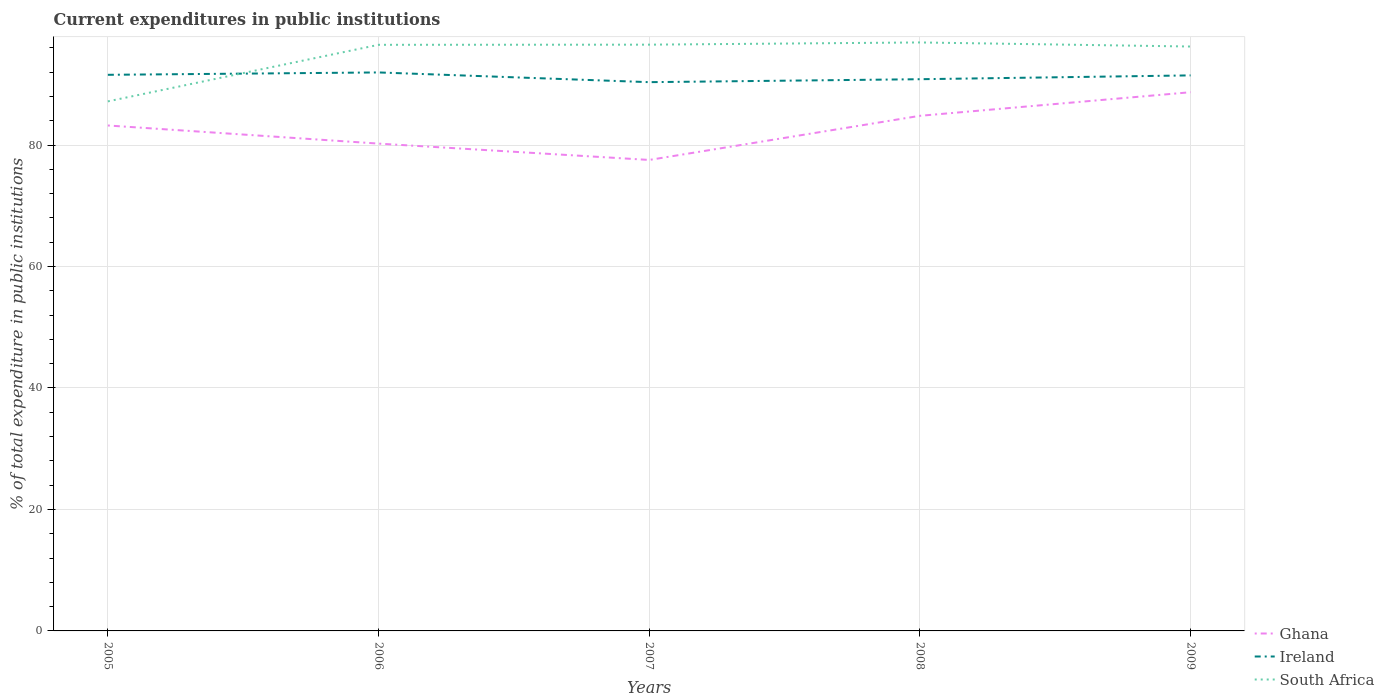How many different coloured lines are there?
Your answer should be very brief. 3. Across all years, what is the maximum current expenditures in public institutions in Ghana?
Offer a very short reply. 77.54. In which year was the current expenditures in public institutions in Ghana maximum?
Offer a very short reply. 2007. What is the total current expenditures in public institutions in Ghana in the graph?
Offer a very short reply. 2.98. What is the difference between the highest and the second highest current expenditures in public institutions in Ghana?
Your answer should be very brief. 11.15. Is the current expenditures in public institutions in South Africa strictly greater than the current expenditures in public institutions in Ghana over the years?
Offer a terse response. No. How many lines are there?
Your answer should be very brief. 3. Does the graph contain any zero values?
Your answer should be very brief. No. Does the graph contain grids?
Offer a terse response. Yes. How many legend labels are there?
Make the answer very short. 3. What is the title of the graph?
Offer a terse response. Current expenditures in public institutions. Does "Djibouti" appear as one of the legend labels in the graph?
Ensure brevity in your answer.  No. What is the label or title of the Y-axis?
Offer a terse response. % of total expenditure in public institutions. What is the % of total expenditure in public institutions of Ghana in 2005?
Your answer should be very brief. 83.22. What is the % of total expenditure in public institutions in Ireland in 2005?
Give a very brief answer. 91.56. What is the % of total expenditure in public institutions in South Africa in 2005?
Your answer should be compact. 87.19. What is the % of total expenditure in public institutions in Ghana in 2006?
Provide a short and direct response. 80.23. What is the % of total expenditure in public institutions in Ireland in 2006?
Ensure brevity in your answer.  91.95. What is the % of total expenditure in public institutions in South Africa in 2006?
Ensure brevity in your answer.  96.5. What is the % of total expenditure in public institutions in Ghana in 2007?
Offer a terse response. 77.54. What is the % of total expenditure in public institutions in Ireland in 2007?
Ensure brevity in your answer.  90.35. What is the % of total expenditure in public institutions of South Africa in 2007?
Provide a short and direct response. 96.53. What is the % of total expenditure in public institutions in Ghana in 2008?
Your answer should be very brief. 84.81. What is the % of total expenditure in public institutions of Ireland in 2008?
Offer a very short reply. 90.84. What is the % of total expenditure in public institutions of South Africa in 2008?
Offer a very short reply. 96.89. What is the % of total expenditure in public institutions in Ghana in 2009?
Keep it short and to the point. 88.7. What is the % of total expenditure in public institutions in Ireland in 2009?
Keep it short and to the point. 91.47. What is the % of total expenditure in public institutions of South Africa in 2009?
Ensure brevity in your answer.  96.22. Across all years, what is the maximum % of total expenditure in public institutions of Ghana?
Ensure brevity in your answer.  88.7. Across all years, what is the maximum % of total expenditure in public institutions in Ireland?
Your answer should be very brief. 91.95. Across all years, what is the maximum % of total expenditure in public institutions of South Africa?
Ensure brevity in your answer.  96.89. Across all years, what is the minimum % of total expenditure in public institutions in Ghana?
Make the answer very short. 77.54. Across all years, what is the minimum % of total expenditure in public institutions of Ireland?
Your response must be concise. 90.35. Across all years, what is the minimum % of total expenditure in public institutions in South Africa?
Ensure brevity in your answer.  87.19. What is the total % of total expenditure in public institutions in Ghana in the graph?
Your answer should be very brief. 414.5. What is the total % of total expenditure in public institutions in Ireland in the graph?
Your answer should be compact. 456.17. What is the total % of total expenditure in public institutions in South Africa in the graph?
Make the answer very short. 473.32. What is the difference between the % of total expenditure in public institutions in Ghana in 2005 and that in 2006?
Give a very brief answer. 2.98. What is the difference between the % of total expenditure in public institutions in Ireland in 2005 and that in 2006?
Ensure brevity in your answer.  -0.39. What is the difference between the % of total expenditure in public institutions of South Africa in 2005 and that in 2006?
Ensure brevity in your answer.  -9.31. What is the difference between the % of total expenditure in public institutions of Ghana in 2005 and that in 2007?
Your answer should be very brief. 5.68. What is the difference between the % of total expenditure in public institutions in Ireland in 2005 and that in 2007?
Offer a terse response. 1.21. What is the difference between the % of total expenditure in public institutions of South Africa in 2005 and that in 2007?
Your answer should be very brief. -9.34. What is the difference between the % of total expenditure in public institutions in Ghana in 2005 and that in 2008?
Keep it short and to the point. -1.59. What is the difference between the % of total expenditure in public institutions in Ireland in 2005 and that in 2008?
Your response must be concise. 0.73. What is the difference between the % of total expenditure in public institutions in South Africa in 2005 and that in 2008?
Ensure brevity in your answer.  -9.7. What is the difference between the % of total expenditure in public institutions of Ghana in 2005 and that in 2009?
Your answer should be very brief. -5.48. What is the difference between the % of total expenditure in public institutions in Ireland in 2005 and that in 2009?
Provide a succinct answer. 0.09. What is the difference between the % of total expenditure in public institutions in South Africa in 2005 and that in 2009?
Provide a succinct answer. -9.03. What is the difference between the % of total expenditure in public institutions of Ghana in 2006 and that in 2007?
Make the answer very short. 2.69. What is the difference between the % of total expenditure in public institutions of Ireland in 2006 and that in 2007?
Offer a terse response. 1.6. What is the difference between the % of total expenditure in public institutions in South Africa in 2006 and that in 2007?
Offer a terse response. -0.03. What is the difference between the % of total expenditure in public institutions in Ghana in 2006 and that in 2008?
Your response must be concise. -4.58. What is the difference between the % of total expenditure in public institutions of Ireland in 2006 and that in 2008?
Provide a short and direct response. 1.12. What is the difference between the % of total expenditure in public institutions in South Africa in 2006 and that in 2008?
Your answer should be compact. -0.39. What is the difference between the % of total expenditure in public institutions of Ghana in 2006 and that in 2009?
Your answer should be very brief. -8.46. What is the difference between the % of total expenditure in public institutions in Ireland in 2006 and that in 2009?
Make the answer very short. 0.49. What is the difference between the % of total expenditure in public institutions in South Africa in 2006 and that in 2009?
Your response must be concise. 0.28. What is the difference between the % of total expenditure in public institutions of Ghana in 2007 and that in 2008?
Offer a very short reply. -7.27. What is the difference between the % of total expenditure in public institutions of Ireland in 2007 and that in 2008?
Your response must be concise. -0.48. What is the difference between the % of total expenditure in public institutions of South Africa in 2007 and that in 2008?
Provide a succinct answer. -0.36. What is the difference between the % of total expenditure in public institutions of Ghana in 2007 and that in 2009?
Give a very brief answer. -11.15. What is the difference between the % of total expenditure in public institutions in Ireland in 2007 and that in 2009?
Your answer should be very brief. -1.12. What is the difference between the % of total expenditure in public institutions of South Africa in 2007 and that in 2009?
Your response must be concise. 0.31. What is the difference between the % of total expenditure in public institutions in Ghana in 2008 and that in 2009?
Ensure brevity in your answer.  -3.89. What is the difference between the % of total expenditure in public institutions in Ireland in 2008 and that in 2009?
Provide a short and direct response. -0.63. What is the difference between the % of total expenditure in public institutions in South Africa in 2008 and that in 2009?
Your answer should be very brief. 0.67. What is the difference between the % of total expenditure in public institutions of Ghana in 2005 and the % of total expenditure in public institutions of Ireland in 2006?
Your response must be concise. -8.73. What is the difference between the % of total expenditure in public institutions in Ghana in 2005 and the % of total expenditure in public institutions in South Africa in 2006?
Provide a succinct answer. -13.28. What is the difference between the % of total expenditure in public institutions of Ireland in 2005 and the % of total expenditure in public institutions of South Africa in 2006?
Your answer should be very brief. -4.94. What is the difference between the % of total expenditure in public institutions in Ghana in 2005 and the % of total expenditure in public institutions in Ireland in 2007?
Offer a very short reply. -7.13. What is the difference between the % of total expenditure in public institutions in Ghana in 2005 and the % of total expenditure in public institutions in South Africa in 2007?
Provide a short and direct response. -13.31. What is the difference between the % of total expenditure in public institutions in Ireland in 2005 and the % of total expenditure in public institutions in South Africa in 2007?
Offer a very short reply. -4.96. What is the difference between the % of total expenditure in public institutions in Ghana in 2005 and the % of total expenditure in public institutions in Ireland in 2008?
Give a very brief answer. -7.62. What is the difference between the % of total expenditure in public institutions of Ghana in 2005 and the % of total expenditure in public institutions of South Africa in 2008?
Keep it short and to the point. -13.67. What is the difference between the % of total expenditure in public institutions in Ireland in 2005 and the % of total expenditure in public institutions in South Africa in 2008?
Offer a very short reply. -5.33. What is the difference between the % of total expenditure in public institutions in Ghana in 2005 and the % of total expenditure in public institutions in Ireland in 2009?
Ensure brevity in your answer.  -8.25. What is the difference between the % of total expenditure in public institutions in Ghana in 2005 and the % of total expenditure in public institutions in South Africa in 2009?
Offer a very short reply. -13. What is the difference between the % of total expenditure in public institutions in Ireland in 2005 and the % of total expenditure in public institutions in South Africa in 2009?
Provide a short and direct response. -4.66. What is the difference between the % of total expenditure in public institutions in Ghana in 2006 and the % of total expenditure in public institutions in Ireland in 2007?
Your response must be concise. -10.12. What is the difference between the % of total expenditure in public institutions in Ghana in 2006 and the % of total expenditure in public institutions in South Africa in 2007?
Provide a succinct answer. -16.29. What is the difference between the % of total expenditure in public institutions in Ireland in 2006 and the % of total expenditure in public institutions in South Africa in 2007?
Provide a short and direct response. -4.57. What is the difference between the % of total expenditure in public institutions of Ghana in 2006 and the % of total expenditure in public institutions of Ireland in 2008?
Provide a short and direct response. -10.6. What is the difference between the % of total expenditure in public institutions in Ghana in 2006 and the % of total expenditure in public institutions in South Africa in 2008?
Make the answer very short. -16.65. What is the difference between the % of total expenditure in public institutions in Ireland in 2006 and the % of total expenditure in public institutions in South Africa in 2008?
Provide a succinct answer. -4.94. What is the difference between the % of total expenditure in public institutions in Ghana in 2006 and the % of total expenditure in public institutions in Ireland in 2009?
Your answer should be compact. -11.23. What is the difference between the % of total expenditure in public institutions in Ghana in 2006 and the % of total expenditure in public institutions in South Africa in 2009?
Your answer should be very brief. -15.98. What is the difference between the % of total expenditure in public institutions in Ireland in 2006 and the % of total expenditure in public institutions in South Africa in 2009?
Your response must be concise. -4.27. What is the difference between the % of total expenditure in public institutions of Ghana in 2007 and the % of total expenditure in public institutions of Ireland in 2008?
Offer a very short reply. -13.29. What is the difference between the % of total expenditure in public institutions of Ghana in 2007 and the % of total expenditure in public institutions of South Africa in 2008?
Your answer should be compact. -19.34. What is the difference between the % of total expenditure in public institutions in Ireland in 2007 and the % of total expenditure in public institutions in South Africa in 2008?
Make the answer very short. -6.54. What is the difference between the % of total expenditure in public institutions of Ghana in 2007 and the % of total expenditure in public institutions of Ireland in 2009?
Your response must be concise. -13.92. What is the difference between the % of total expenditure in public institutions of Ghana in 2007 and the % of total expenditure in public institutions of South Africa in 2009?
Your response must be concise. -18.67. What is the difference between the % of total expenditure in public institutions in Ireland in 2007 and the % of total expenditure in public institutions in South Africa in 2009?
Make the answer very short. -5.87. What is the difference between the % of total expenditure in public institutions of Ghana in 2008 and the % of total expenditure in public institutions of Ireland in 2009?
Keep it short and to the point. -6.66. What is the difference between the % of total expenditure in public institutions of Ghana in 2008 and the % of total expenditure in public institutions of South Africa in 2009?
Provide a short and direct response. -11.41. What is the difference between the % of total expenditure in public institutions of Ireland in 2008 and the % of total expenditure in public institutions of South Africa in 2009?
Ensure brevity in your answer.  -5.38. What is the average % of total expenditure in public institutions of Ghana per year?
Make the answer very short. 82.9. What is the average % of total expenditure in public institutions in Ireland per year?
Give a very brief answer. 91.23. What is the average % of total expenditure in public institutions in South Africa per year?
Make the answer very short. 94.66. In the year 2005, what is the difference between the % of total expenditure in public institutions in Ghana and % of total expenditure in public institutions in Ireland?
Your answer should be very brief. -8.34. In the year 2005, what is the difference between the % of total expenditure in public institutions in Ghana and % of total expenditure in public institutions in South Africa?
Make the answer very short. -3.97. In the year 2005, what is the difference between the % of total expenditure in public institutions in Ireland and % of total expenditure in public institutions in South Africa?
Give a very brief answer. 4.37. In the year 2006, what is the difference between the % of total expenditure in public institutions in Ghana and % of total expenditure in public institutions in Ireland?
Keep it short and to the point. -11.72. In the year 2006, what is the difference between the % of total expenditure in public institutions in Ghana and % of total expenditure in public institutions in South Africa?
Offer a terse response. -16.27. In the year 2006, what is the difference between the % of total expenditure in public institutions of Ireland and % of total expenditure in public institutions of South Africa?
Make the answer very short. -4.55. In the year 2007, what is the difference between the % of total expenditure in public institutions of Ghana and % of total expenditure in public institutions of Ireland?
Offer a terse response. -12.81. In the year 2007, what is the difference between the % of total expenditure in public institutions of Ghana and % of total expenditure in public institutions of South Africa?
Provide a succinct answer. -18.98. In the year 2007, what is the difference between the % of total expenditure in public institutions of Ireland and % of total expenditure in public institutions of South Africa?
Provide a succinct answer. -6.17. In the year 2008, what is the difference between the % of total expenditure in public institutions of Ghana and % of total expenditure in public institutions of Ireland?
Your answer should be very brief. -6.03. In the year 2008, what is the difference between the % of total expenditure in public institutions in Ghana and % of total expenditure in public institutions in South Africa?
Make the answer very short. -12.08. In the year 2008, what is the difference between the % of total expenditure in public institutions of Ireland and % of total expenditure in public institutions of South Africa?
Provide a short and direct response. -6.05. In the year 2009, what is the difference between the % of total expenditure in public institutions in Ghana and % of total expenditure in public institutions in Ireland?
Ensure brevity in your answer.  -2.77. In the year 2009, what is the difference between the % of total expenditure in public institutions of Ghana and % of total expenditure in public institutions of South Africa?
Your response must be concise. -7.52. In the year 2009, what is the difference between the % of total expenditure in public institutions of Ireland and % of total expenditure in public institutions of South Africa?
Provide a succinct answer. -4.75. What is the ratio of the % of total expenditure in public institutions of Ghana in 2005 to that in 2006?
Offer a terse response. 1.04. What is the ratio of the % of total expenditure in public institutions of South Africa in 2005 to that in 2006?
Make the answer very short. 0.9. What is the ratio of the % of total expenditure in public institutions in Ghana in 2005 to that in 2007?
Your answer should be compact. 1.07. What is the ratio of the % of total expenditure in public institutions in Ireland in 2005 to that in 2007?
Give a very brief answer. 1.01. What is the ratio of the % of total expenditure in public institutions of South Africa in 2005 to that in 2007?
Provide a short and direct response. 0.9. What is the ratio of the % of total expenditure in public institutions of Ghana in 2005 to that in 2008?
Provide a short and direct response. 0.98. What is the ratio of the % of total expenditure in public institutions of South Africa in 2005 to that in 2008?
Your answer should be compact. 0.9. What is the ratio of the % of total expenditure in public institutions in Ghana in 2005 to that in 2009?
Your response must be concise. 0.94. What is the ratio of the % of total expenditure in public institutions in South Africa in 2005 to that in 2009?
Your answer should be very brief. 0.91. What is the ratio of the % of total expenditure in public institutions in Ghana in 2006 to that in 2007?
Give a very brief answer. 1.03. What is the ratio of the % of total expenditure in public institutions in Ireland in 2006 to that in 2007?
Offer a very short reply. 1.02. What is the ratio of the % of total expenditure in public institutions of South Africa in 2006 to that in 2007?
Offer a terse response. 1. What is the ratio of the % of total expenditure in public institutions of Ghana in 2006 to that in 2008?
Keep it short and to the point. 0.95. What is the ratio of the % of total expenditure in public institutions in Ireland in 2006 to that in 2008?
Your response must be concise. 1.01. What is the ratio of the % of total expenditure in public institutions in Ghana in 2006 to that in 2009?
Provide a succinct answer. 0.9. What is the ratio of the % of total expenditure in public institutions of Ireland in 2006 to that in 2009?
Make the answer very short. 1.01. What is the ratio of the % of total expenditure in public institutions of South Africa in 2006 to that in 2009?
Make the answer very short. 1. What is the ratio of the % of total expenditure in public institutions in Ghana in 2007 to that in 2008?
Provide a succinct answer. 0.91. What is the ratio of the % of total expenditure in public institutions in South Africa in 2007 to that in 2008?
Your response must be concise. 1. What is the ratio of the % of total expenditure in public institutions of Ghana in 2007 to that in 2009?
Offer a very short reply. 0.87. What is the ratio of the % of total expenditure in public institutions of Ireland in 2007 to that in 2009?
Offer a terse response. 0.99. What is the ratio of the % of total expenditure in public institutions of South Africa in 2007 to that in 2009?
Make the answer very short. 1. What is the ratio of the % of total expenditure in public institutions of Ghana in 2008 to that in 2009?
Offer a very short reply. 0.96. What is the ratio of the % of total expenditure in public institutions in South Africa in 2008 to that in 2009?
Offer a terse response. 1.01. What is the difference between the highest and the second highest % of total expenditure in public institutions in Ghana?
Provide a succinct answer. 3.89. What is the difference between the highest and the second highest % of total expenditure in public institutions in Ireland?
Give a very brief answer. 0.39. What is the difference between the highest and the second highest % of total expenditure in public institutions in South Africa?
Keep it short and to the point. 0.36. What is the difference between the highest and the lowest % of total expenditure in public institutions in Ghana?
Your answer should be very brief. 11.15. What is the difference between the highest and the lowest % of total expenditure in public institutions of Ireland?
Provide a succinct answer. 1.6. What is the difference between the highest and the lowest % of total expenditure in public institutions of South Africa?
Provide a short and direct response. 9.7. 